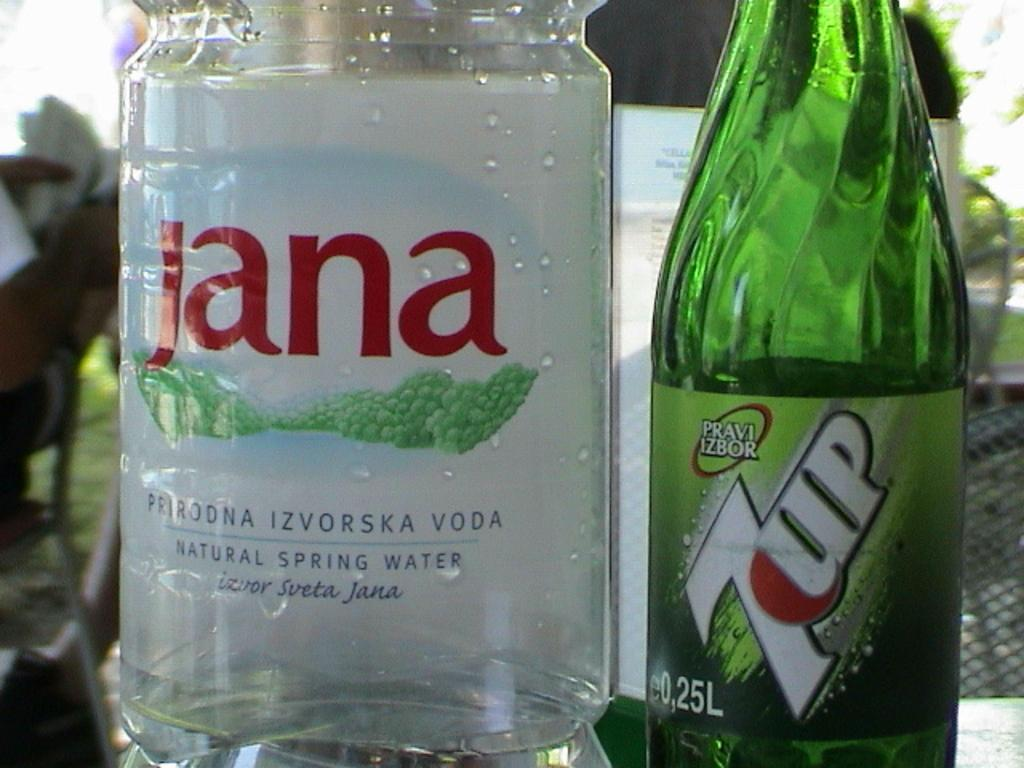What objects are on the table in the image? There are different color bottles on a table in the image. What decorations are on the bottles? There are stickers on the bottles. What can be seen in the background of the image? There are persons and chairs in the background of the image. How many quarters can be seen on the table in the image? There are no quarters visible on the table in the image. What type of sand is present on the table in the image? There is no sand present on the table in the image. 